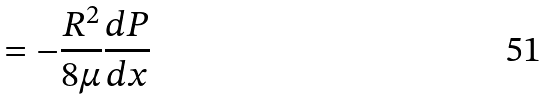<formula> <loc_0><loc_0><loc_500><loc_500>= - \frac { R ^ { 2 } } { 8 \mu } \frac { d P } { d x }</formula> 